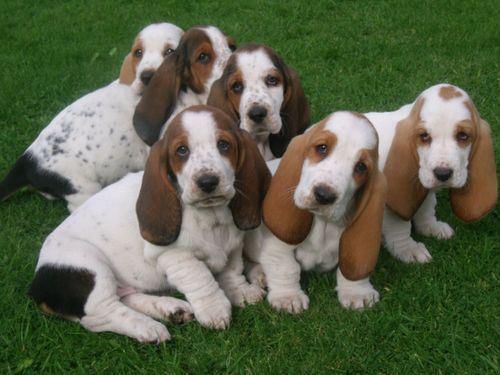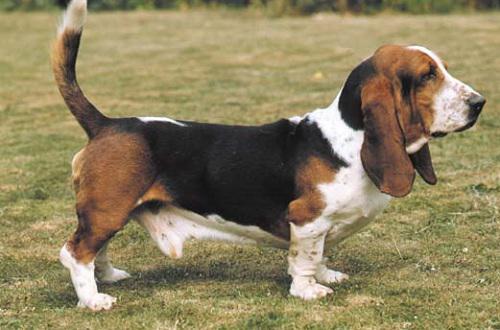The first image is the image on the left, the second image is the image on the right. Considering the images on both sides, is "One of the dogs is right next to a human, and being touched by the human." valid? Answer yes or no. No. The first image is the image on the left, the second image is the image on the right. Evaluate the accuracy of this statement regarding the images: "One image shows a basset hound being touched by a human hand.". Is it true? Answer yes or no. No. 